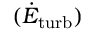Convert formula to latex. <formula><loc_0><loc_0><loc_500><loc_500>( \dot { E } _ { t u r b } )</formula> 